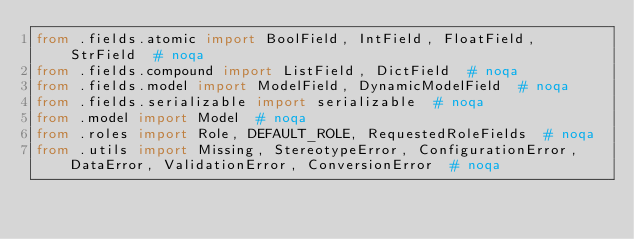<code> <loc_0><loc_0><loc_500><loc_500><_Python_>from .fields.atomic import BoolField, IntField, FloatField, StrField  # noqa
from .fields.compound import ListField, DictField  # noqa
from .fields.model import ModelField, DynamicModelField  # noqa
from .fields.serializable import serializable  # noqa
from .model import Model  # noqa
from .roles import Role, DEFAULT_ROLE, RequestedRoleFields  # noqa
from .utils import Missing, StereotypeError, ConfigurationError, DataError, ValidationError, ConversionError  # noqa
</code> 